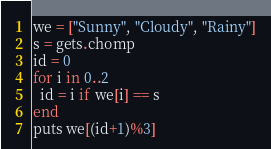Convert code to text. <code><loc_0><loc_0><loc_500><loc_500><_Ruby_>we = ["Sunny", "Cloudy", "Rainy"]
s = gets.chomp
id = 0
for i in 0..2
  id = i if we[i] == s
end
puts we[(id+1)%3]</code> 